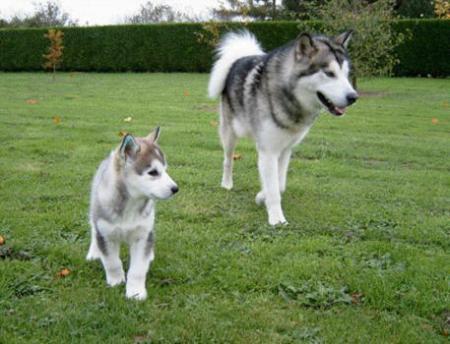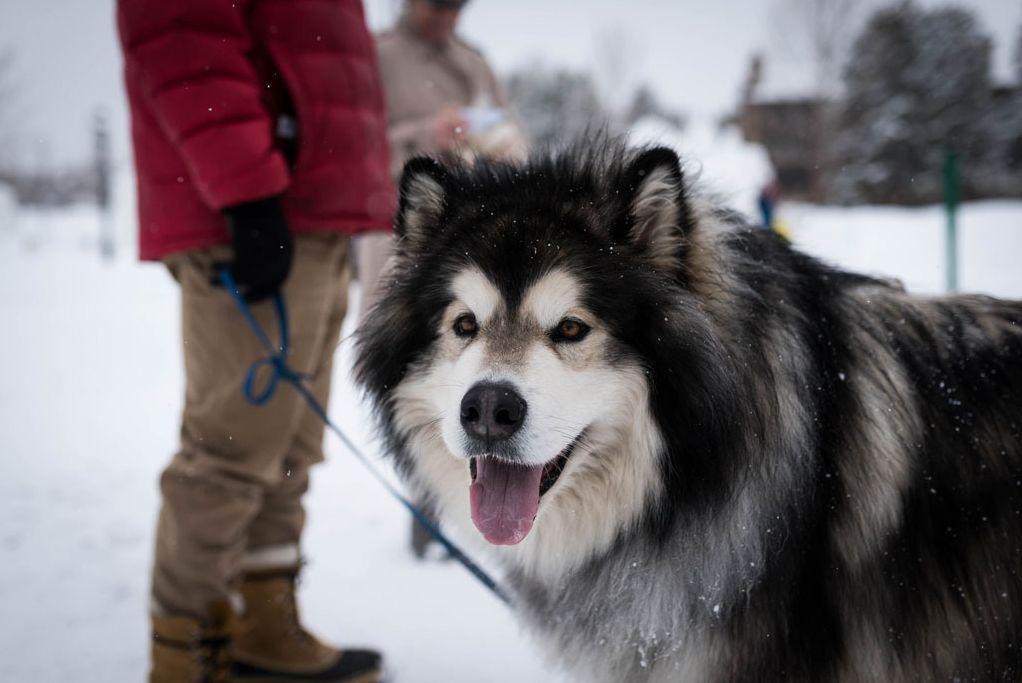The first image is the image on the left, the second image is the image on the right. Considering the images on both sides, is "Both dogs have their tongues hanging out." valid? Answer yes or no. No. The first image is the image on the left, the second image is the image on the right. Assess this claim about the two images: "Each image contains one dog, each dog has its tongue hanging down, one dog is sitting upright, and one dog is standing.". Correct or not? Answer yes or no. No. 